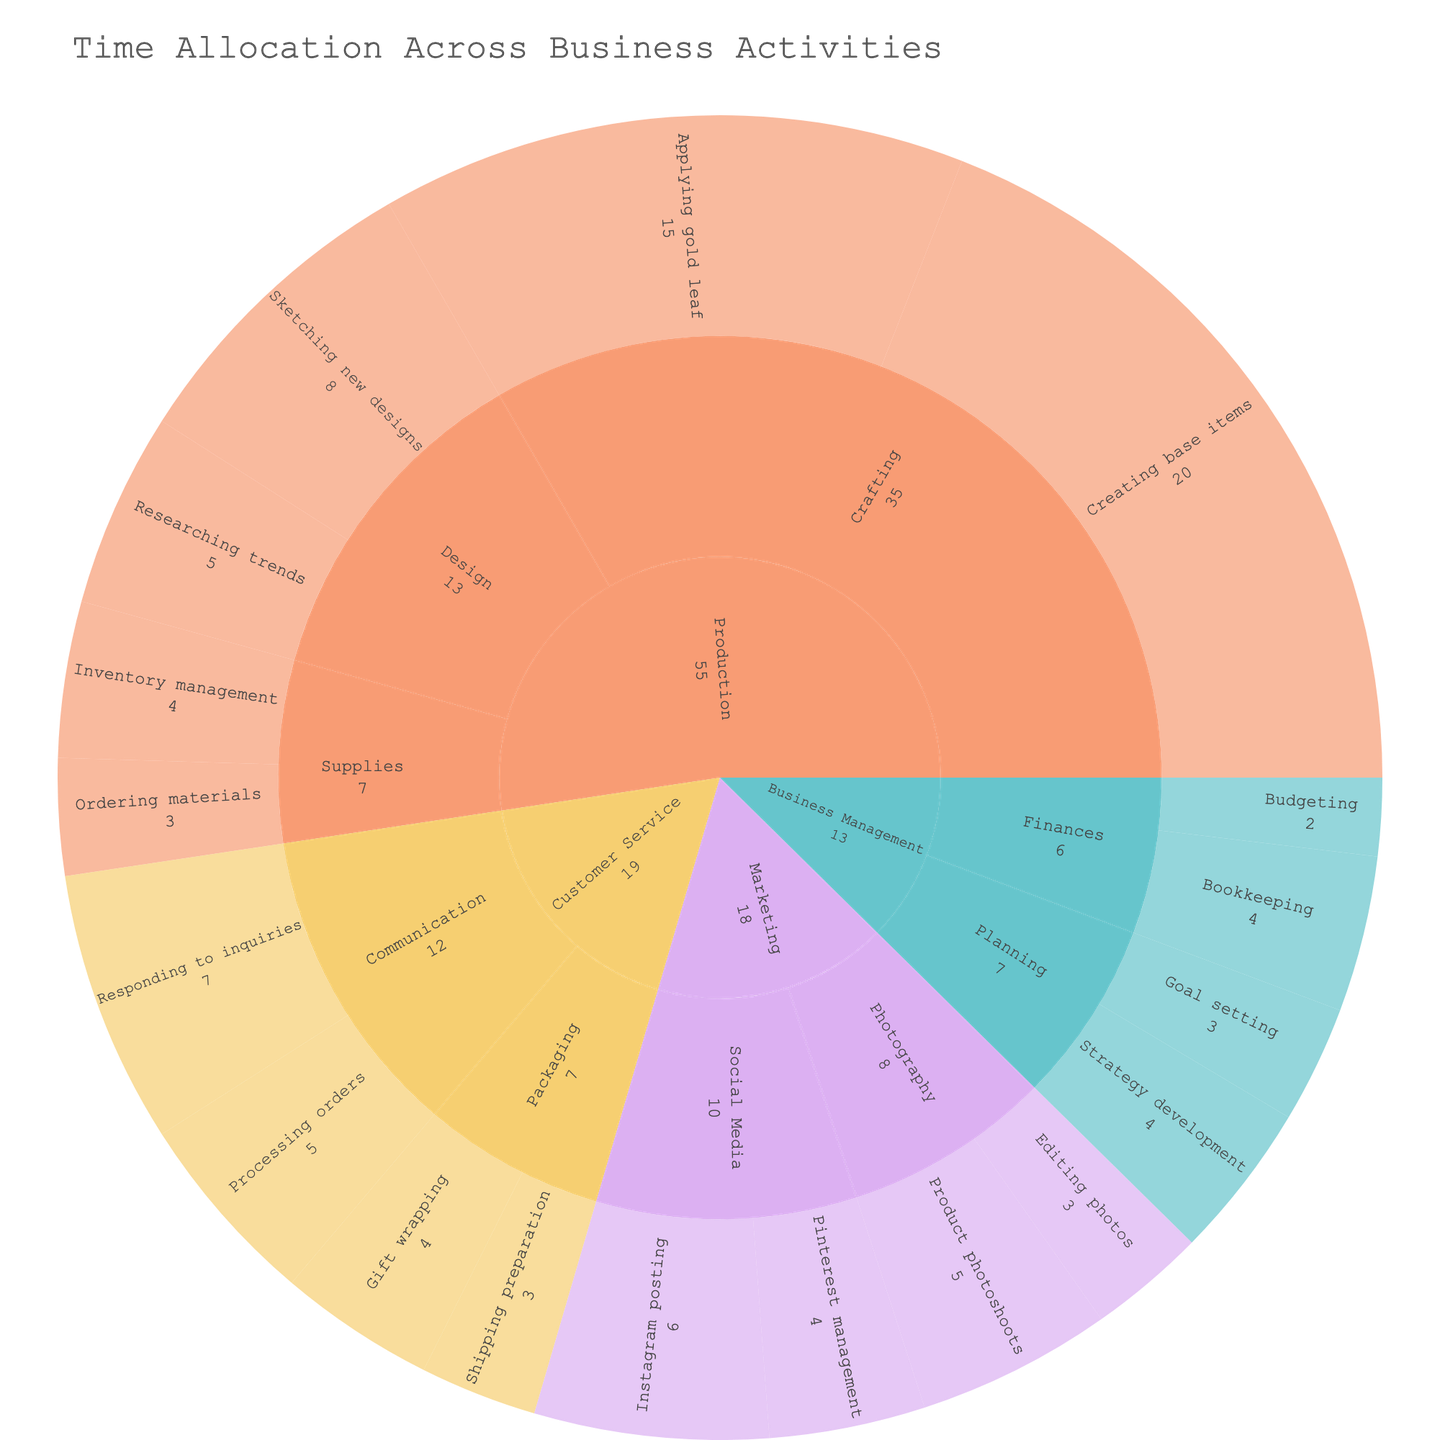What's the title of the plot? The title is displayed at the top center of the plot, and it summarizes what the visual represents.
Answer: Time Allocation Across Business Activities Which category has the highest total number of hours? By looking at the largest segment at the top level of the sunburst, you can compare the total hours visually. The production segment appears to be the largest.
Answer: Production How many hours are spent on Marketing activities? Find the Marketing segment in the sunburst chart and sum up the hours for all its subcategories and activities.
Answer: 18 hours In which subcategory is "Gift wrapping" categorized, and how many hours are spent on it? Locate the "Gift wrapping" activity by following its path from the outermost ring to the center. It is under Customer Service -> Packaging.
Answer: 4 hours Which activity in the Production category takes the most hours? Look within the Production category and evaluate all activities by their size. "Creating base items" and "Applying gold leaf" are the largest. "Creating base items" has more hours.
Answer: Creating base items How do the hours spent on "Sketching new designs" compare to those spent on "Editing photos"? Find the hours for each activity and compare them. "Sketching new designs" has 8 hours and "Editing photos" has 3 hours.
Answer: Sketching new designs takes 5 more hours Which subcategories fall under Business Management? Identify the segments branching out from Business Management; these are its subcategories.
Answer: Finances, Planning Which activity takes more time: "Responding to inquiries" or "Goal setting"? Compare the hours of "Responding to inquiries" and "Goal setting" by checking their size and numerical value.
Answer: Responding to inquiries (7 hours) takes more time What proportion of time is spent on "Ordering materials" relative to the Production category as a whole? First, find the hours for "Ordering materials" (3 hours). Then, sum up all hours under Production (20 + 15 + 8 + 5 + 3 + 4 = 55 hours). Divide the hours of "Ordering materials" by the total Production hours and multiply by 100 for the percentage.
Answer: Approximately 5.5% Combining "Social Media" and "Photography," how many hours are attributed to Marketing? Sum the hours in the subcategories "Social Media" (6 + 4) and "Photography" (5 + 3) to find the total.
Answer: 18 hours 